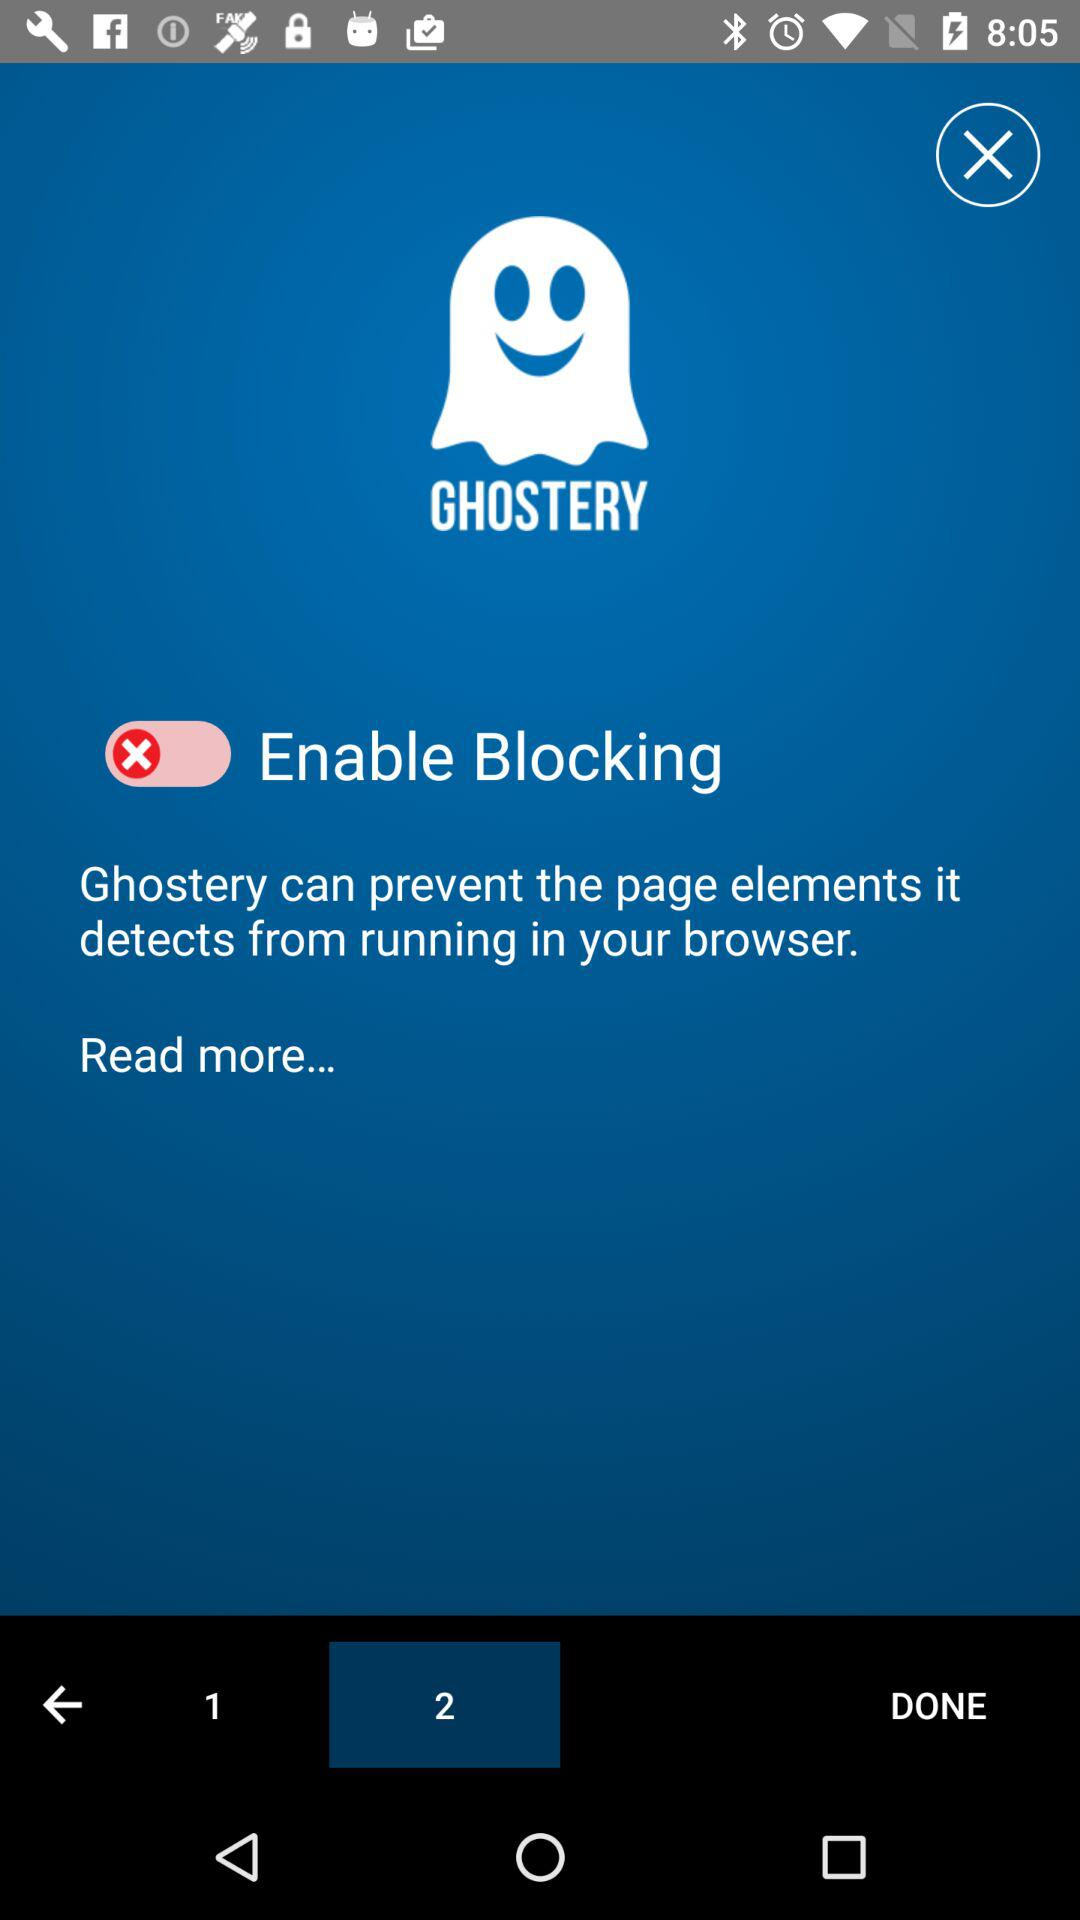What is the app name? The app name is "GHOSTERY". 